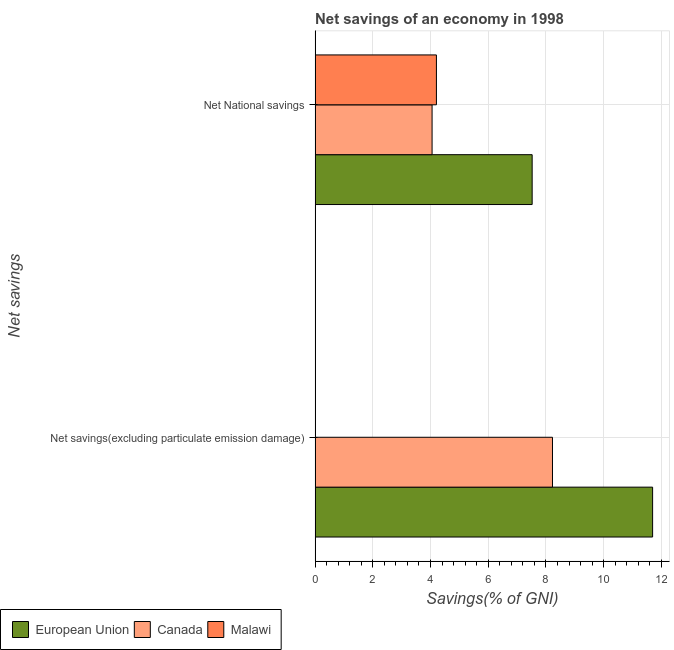How many different coloured bars are there?
Make the answer very short. 3. How many groups of bars are there?
Your response must be concise. 2. Are the number of bars on each tick of the Y-axis equal?
Provide a succinct answer. No. How many bars are there on the 1st tick from the bottom?
Your answer should be compact. 2. What is the label of the 2nd group of bars from the top?
Offer a terse response. Net savings(excluding particulate emission damage). Across all countries, what is the maximum net savings(excluding particulate emission damage)?
Give a very brief answer. 11.7. Across all countries, what is the minimum net national savings?
Make the answer very short. 4.05. In which country was the net national savings maximum?
Your answer should be compact. European Union. What is the total net savings(excluding particulate emission damage) in the graph?
Give a very brief answer. 19.92. What is the difference between the net national savings in Malawi and that in European Union?
Offer a terse response. -3.32. What is the difference between the net national savings in Malawi and the net savings(excluding particulate emission damage) in European Union?
Your answer should be compact. -7.49. What is the average net savings(excluding particulate emission damage) per country?
Your response must be concise. 6.64. What is the difference between the net national savings and net savings(excluding particulate emission damage) in European Union?
Your answer should be compact. -4.17. What is the ratio of the net national savings in European Union to that in Canada?
Keep it short and to the point. 1.86. Is the net national savings in Canada less than that in Malawi?
Give a very brief answer. Yes. In how many countries, is the net savings(excluding particulate emission damage) greater than the average net savings(excluding particulate emission damage) taken over all countries?
Provide a succinct answer. 2. How many bars are there?
Give a very brief answer. 5. Are all the bars in the graph horizontal?
Provide a succinct answer. Yes. Does the graph contain grids?
Provide a succinct answer. Yes. Where does the legend appear in the graph?
Offer a terse response. Bottom left. How many legend labels are there?
Make the answer very short. 3. How are the legend labels stacked?
Offer a very short reply. Horizontal. What is the title of the graph?
Keep it short and to the point. Net savings of an economy in 1998. Does "Northern Mariana Islands" appear as one of the legend labels in the graph?
Provide a succinct answer. No. What is the label or title of the X-axis?
Offer a terse response. Savings(% of GNI). What is the label or title of the Y-axis?
Provide a short and direct response. Net savings. What is the Savings(% of GNI) in European Union in Net savings(excluding particulate emission damage)?
Ensure brevity in your answer.  11.7. What is the Savings(% of GNI) in Canada in Net savings(excluding particulate emission damage)?
Give a very brief answer. 8.23. What is the Savings(% of GNI) of Malawi in Net savings(excluding particulate emission damage)?
Keep it short and to the point. 0. What is the Savings(% of GNI) in European Union in Net National savings?
Your response must be concise. 7.52. What is the Savings(% of GNI) in Canada in Net National savings?
Your response must be concise. 4.05. What is the Savings(% of GNI) in Malawi in Net National savings?
Your answer should be very brief. 4.2. Across all Net savings, what is the maximum Savings(% of GNI) of European Union?
Provide a short and direct response. 11.7. Across all Net savings, what is the maximum Savings(% of GNI) of Canada?
Your response must be concise. 8.23. Across all Net savings, what is the maximum Savings(% of GNI) in Malawi?
Provide a short and direct response. 4.2. Across all Net savings, what is the minimum Savings(% of GNI) in European Union?
Your answer should be very brief. 7.52. Across all Net savings, what is the minimum Savings(% of GNI) of Canada?
Offer a very short reply. 4.05. What is the total Savings(% of GNI) of European Union in the graph?
Ensure brevity in your answer.  19.22. What is the total Savings(% of GNI) in Canada in the graph?
Provide a succinct answer. 12.28. What is the total Savings(% of GNI) of Malawi in the graph?
Provide a short and direct response. 4.2. What is the difference between the Savings(% of GNI) in European Union in Net savings(excluding particulate emission damage) and that in Net National savings?
Keep it short and to the point. 4.17. What is the difference between the Savings(% of GNI) of Canada in Net savings(excluding particulate emission damage) and that in Net National savings?
Make the answer very short. 4.17. What is the difference between the Savings(% of GNI) of European Union in Net savings(excluding particulate emission damage) and the Savings(% of GNI) of Canada in Net National savings?
Your answer should be very brief. 7.64. What is the difference between the Savings(% of GNI) in European Union in Net savings(excluding particulate emission damage) and the Savings(% of GNI) in Malawi in Net National savings?
Ensure brevity in your answer.  7.49. What is the difference between the Savings(% of GNI) of Canada in Net savings(excluding particulate emission damage) and the Savings(% of GNI) of Malawi in Net National savings?
Your response must be concise. 4.02. What is the average Savings(% of GNI) of European Union per Net savings?
Provide a short and direct response. 9.61. What is the average Savings(% of GNI) in Canada per Net savings?
Give a very brief answer. 6.14. What is the average Savings(% of GNI) of Malawi per Net savings?
Offer a very short reply. 2.1. What is the difference between the Savings(% of GNI) in European Union and Savings(% of GNI) in Canada in Net savings(excluding particulate emission damage)?
Your answer should be compact. 3.47. What is the difference between the Savings(% of GNI) in European Union and Savings(% of GNI) in Canada in Net National savings?
Make the answer very short. 3.47. What is the difference between the Savings(% of GNI) in European Union and Savings(% of GNI) in Malawi in Net National savings?
Your answer should be very brief. 3.32. What is the difference between the Savings(% of GNI) in Canada and Savings(% of GNI) in Malawi in Net National savings?
Give a very brief answer. -0.15. What is the ratio of the Savings(% of GNI) in European Union in Net savings(excluding particulate emission damage) to that in Net National savings?
Provide a succinct answer. 1.55. What is the ratio of the Savings(% of GNI) of Canada in Net savings(excluding particulate emission damage) to that in Net National savings?
Give a very brief answer. 2.03. What is the difference between the highest and the second highest Savings(% of GNI) in European Union?
Give a very brief answer. 4.17. What is the difference between the highest and the second highest Savings(% of GNI) of Canada?
Provide a succinct answer. 4.17. What is the difference between the highest and the lowest Savings(% of GNI) of European Union?
Make the answer very short. 4.17. What is the difference between the highest and the lowest Savings(% of GNI) of Canada?
Your response must be concise. 4.17. What is the difference between the highest and the lowest Savings(% of GNI) of Malawi?
Your answer should be compact. 4.2. 